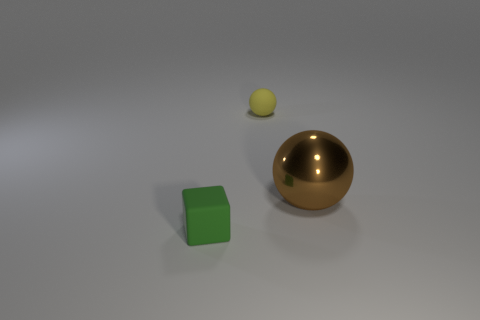Is there any other thing that has the same shape as the tiny green object?
Your response must be concise. No. There is a small rubber cube; how many yellow objects are in front of it?
Provide a short and direct response. 0. There is a small thing on the left side of the small matte object that is behind the big brown thing; what shape is it?
Your response must be concise. Cube. There is a tiny green thing that is the same material as the yellow sphere; what is its shape?
Your answer should be very brief. Cube. There is a thing to the right of the yellow ball; does it have the same size as the matte thing that is on the right side of the green thing?
Offer a terse response. No. There is a small object that is in front of the tiny sphere; what shape is it?
Your answer should be very brief. Cube. What color is the big object?
Offer a terse response. Brown. Do the metallic sphere and the object that is left of the small sphere have the same size?
Give a very brief answer. No. What number of rubber objects are either cubes or tiny brown balls?
Your answer should be very brief. 1. Are there any other things that have the same material as the brown object?
Your answer should be very brief. No. 